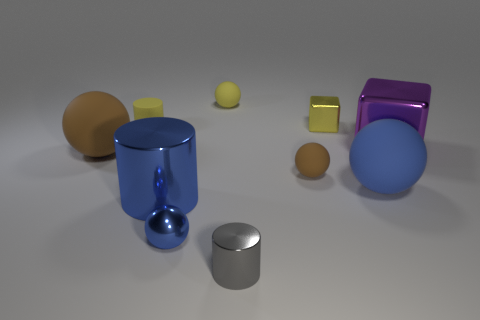Is there anything else of the same color as the tiny block?
Your answer should be very brief. Yes. What is the color of the shiny thing that is right of the shiny object that is behind the big purple thing?
Your answer should be very brief. Purple. Are there fewer metallic balls on the left side of the large brown rubber ball than small cubes that are behind the small blue sphere?
Ensure brevity in your answer.  Yes. There is a big object that is the same color as the large cylinder; what is it made of?
Your response must be concise. Rubber. What number of objects are objects behind the tiny yellow rubber cylinder or small yellow matte cylinders?
Offer a terse response. 3. There is a yellow object that is on the right side of the yellow sphere; is its size the same as the small gray metallic cylinder?
Ensure brevity in your answer.  Yes. Are there fewer matte things that are in front of the shiny ball than red spheres?
Give a very brief answer. No. What is the material of the gray object that is the same size as the metal sphere?
Offer a very short reply. Metal. How many tiny objects are either blue metal cylinders or blue matte objects?
Give a very brief answer. 0. What number of things are brown rubber objects on the left side of the large blue cylinder or tiny metallic objects right of the small blue ball?
Offer a very short reply. 3. 